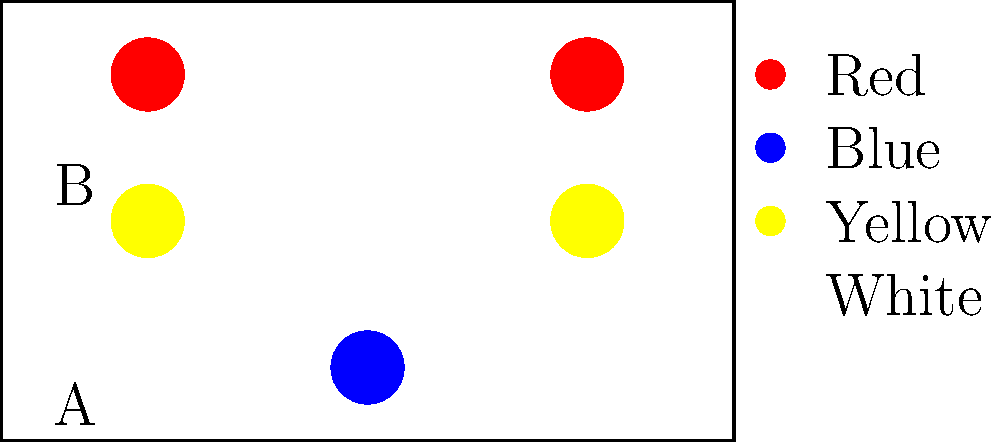Which lighting setup would be more appropriate for creating a sense of tension and conflict in a dramatic scene, considering Stanislavski's emphasis on emotional truth? To answer this question, we need to analyze both lighting setups and their emotional impact, considering Stanislavski's system:

1. Setup A:
   - Two red spotlights at the top corners
   - One blue spotlight at the bottom center
   - Red typically symbolizes intensity, passion, or danger
   - Blue often represents calmness or sadness
   - The contrasting colors create visual tension

2. Setup B:
   - Two yellow spotlights at the middle sides
   - One white spotlight at the top center
   - Yellow often symbolizes happiness or warmth
   - White light is neutral and provides general illumination
   - This setup creates a more balanced and less dramatic atmosphere

3. Stanislavski's system emphasizes emotional truth and realism in acting. For a scene with tension and conflict:
   - We want lighting that enhances the emotional state of the characters
   - Contrasting colors can symbolize opposing forces or internal struggles
   - Intense colors like red can heighten the sense of drama

4. Considering these factors:
   - Setup A with its red and blue contrast creates more visual and emotional tension
   - The top-down lighting in Setup A can create stronger shadows, adding to the dramatic effect
   - Setup B's warmer tones are less suitable for conveying conflict

Therefore, Setup A would be more appropriate for creating a sense of tension and conflict in a dramatic scene, aligning with Stanislavski's emphasis on emotional truth.
Answer: Setup A 